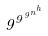<formula> <loc_0><loc_0><loc_500><loc_500>9 ^ { 9 ^ { 9 ^ { n ^ { h } } } }</formula> 